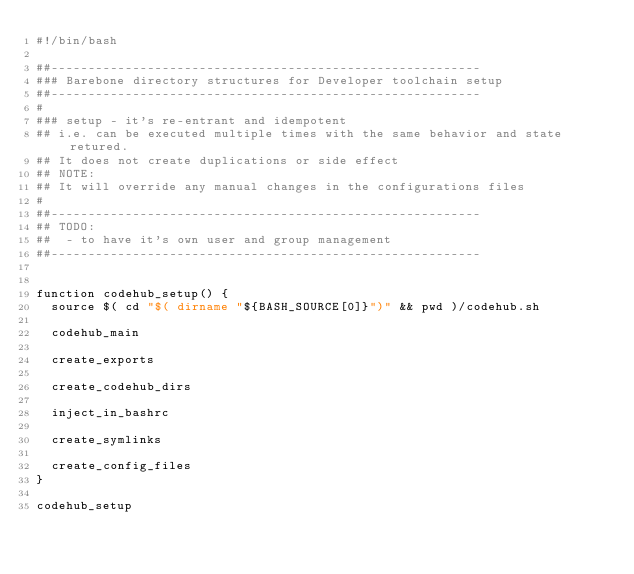Convert code to text. <code><loc_0><loc_0><loc_500><loc_500><_Bash_>#!/bin/bash

##----------------------------------------------------------
### Barebone directory structures for Developer toolchain setup
##----------------------------------------------------------
#
### setup - it's re-entrant and idempotent
## i.e. can be executed multiple times with the same behavior and state retured.
## It does not create duplications or side effect
## NOTE:
## It will override any manual changes in the configurations files
#
##----------------------------------------------------------
## TODO:
##  - to have it's own user and group management
##----------------------------------------------------------


function codehub_setup() {
  source $( cd "$( dirname "${BASH_SOURCE[0]}")" && pwd )/codehub.sh

  codehub_main

  create_exports

  create_codehub_dirs

  inject_in_bashrc

  create_symlinks

  create_config_files
}

codehub_setup
</code> 